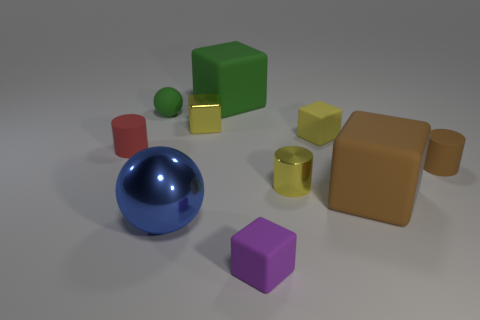Are there any yellow metallic cylinders of the same size as the brown cylinder?
Your response must be concise. Yes. There is a sphere behind the red object; is its size the same as the small metallic block?
Give a very brief answer. Yes. Are there more small cyan rubber balls than purple cubes?
Give a very brief answer. No. Is there a large rubber object of the same shape as the tiny brown rubber thing?
Your answer should be very brief. No. What is the shape of the large thing right of the tiny yellow metal cylinder?
Your answer should be very brief. Cube. There is a small rubber thing in front of the thing that is on the right side of the large brown rubber object; how many rubber objects are behind it?
Give a very brief answer. 6. Is the color of the big matte thing that is on the left side of the purple cube the same as the tiny matte sphere?
Your answer should be very brief. Yes. How many other things are there of the same shape as the small green matte thing?
Your answer should be compact. 1. How many other things are there of the same material as the small yellow cylinder?
Your answer should be compact. 2. What is the material of the yellow block that is behind the small matte cube behind the small red matte cylinder that is in front of the small green ball?
Provide a short and direct response. Metal. 